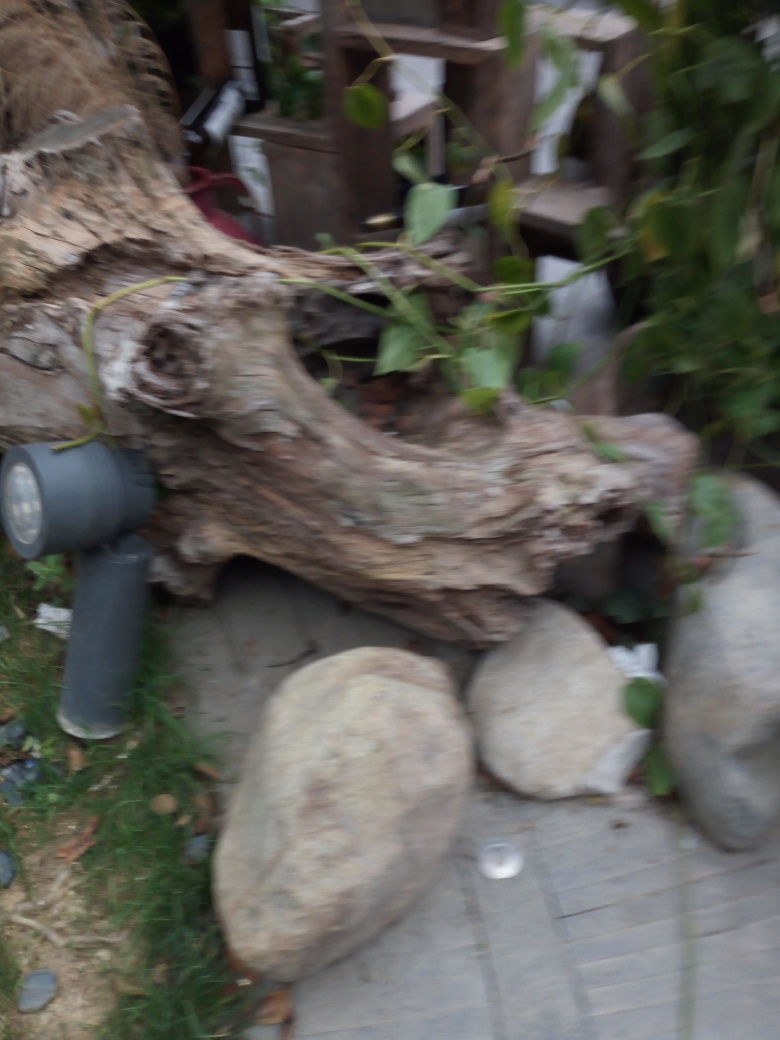How does the image appear?
A. Clear
B. Sharp
C. Blurry
D. Fuzzy
Answer with the option's letter from the given choices directly. The image is quite blurry, which makes the details difficult to discern. This lack of sharpness could be due to camera motion during the exposure or an incorrect focus setting. To ensure the image properly reflects the scene, it would be ideal to stabilize the camera and adjust the focus settings before taking the photo. 